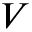<formula> <loc_0><loc_0><loc_500><loc_500>V</formula> 